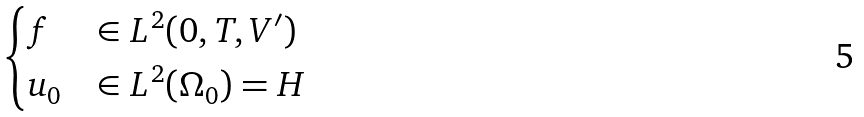<formula> <loc_0><loc_0><loc_500><loc_500>\begin{cases} f & \in L ^ { 2 } ( 0 , T , V ^ { \prime } ) \\ u _ { 0 } & \in L ^ { 2 } ( \Omega _ { 0 } ) = H \end{cases}</formula> 